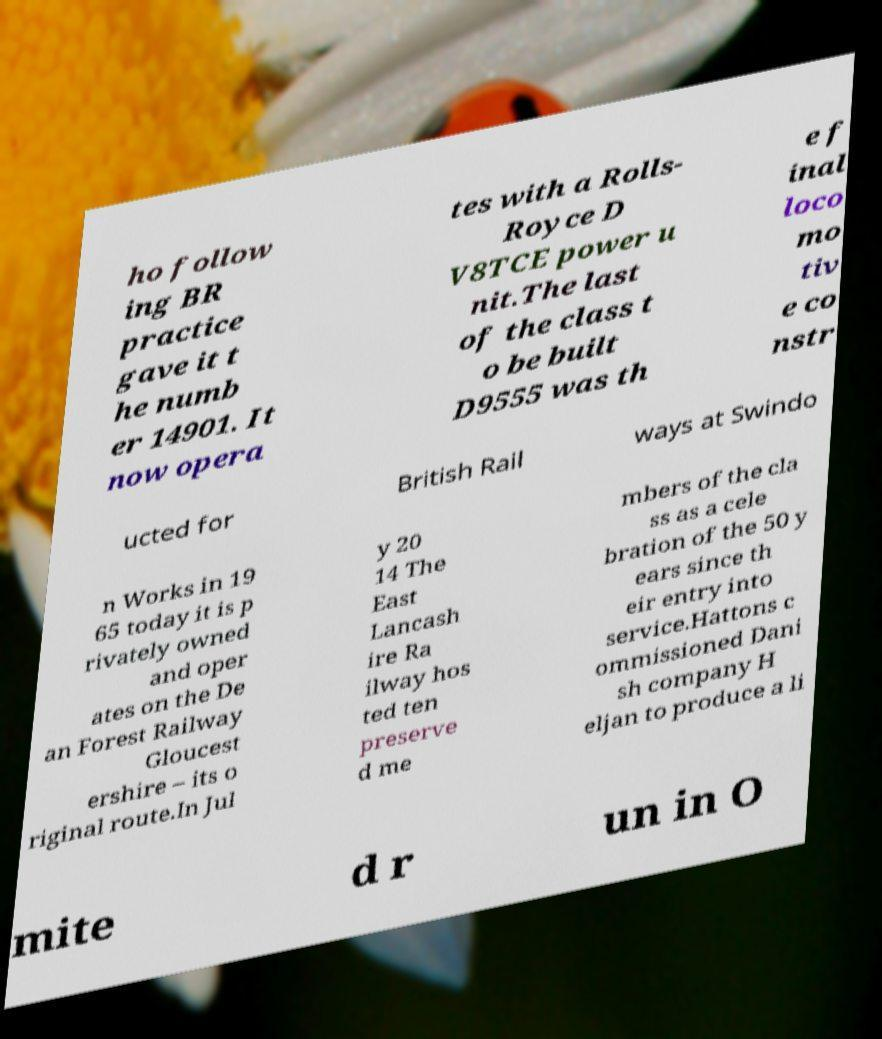What messages or text are displayed in this image? I need them in a readable, typed format. ho follow ing BR practice gave it t he numb er 14901. It now opera tes with a Rolls- Royce D V8TCE power u nit.The last of the class t o be built D9555 was th e f inal loco mo tiv e co nstr ucted for British Rail ways at Swindo n Works in 19 65 today it is p rivately owned and oper ates on the De an Forest Railway Gloucest ershire – its o riginal route.In Jul y 20 14 The East Lancash ire Ra ilway hos ted ten preserve d me mbers of the cla ss as a cele bration of the 50 y ears since th eir entry into service.Hattons c ommissioned Dani sh company H eljan to produce a li mite d r un in O 